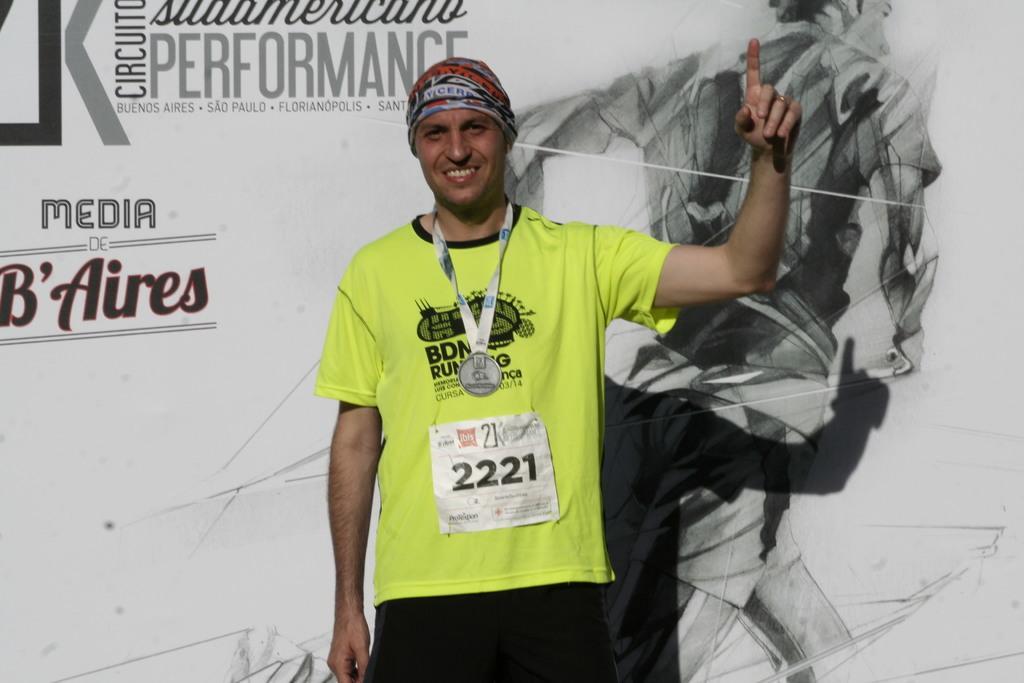Could you give a brief overview of what you see in this image? In this picture there is a person wearing light green color dress is standing and there is a banner behind him. 